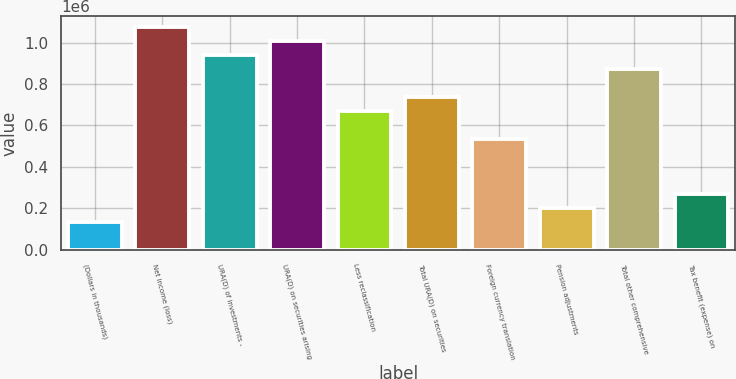Convert chart to OTSL. <chart><loc_0><loc_0><loc_500><loc_500><bar_chart><fcel>(Dollars in thousands)<fcel>Net income (loss)<fcel>URA(D) of investments -<fcel>URA(D) on securities arising<fcel>Less reclassification<fcel>Total URA(D) on securities<fcel>Foreign currency translation<fcel>Pension adjustments<fcel>Total other comprehensive<fcel>Tax benefit (expense) on<nl><fcel>134976<fcel>1.07297e+06<fcel>938973<fcel>1.00597e+06<fcel>670974<fcel>737974<fcel>536975<fcel>201976<fcel>871973<fcel>268976<nl></chart> 